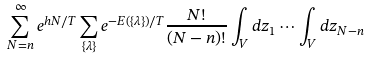Convert formula to latex. <formula><loc_0><loc_0><loc_500><loc_500>\sum _ { N = n } ^ { \infty } e ^ { h N / T } \sum _ { \{ \lambda \} } e ^ { - E ( \{ \lambda \} ) / T } \frac { N ! } { ( N - n ) ! } \int _ { V } d z _ { 1 } \cdots \int _ { V } d z _ { N - n } \</formula> 